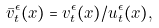<formula> <loc_0><loc_0><loc_500><loc_500>\bar { v } ^ { \epsilon } _ { t } ( x ) = v ^ { \epsilon } _ { t } ( x ) / u ^ { \epsilon } _ { t } ( x ) ,</formula> 